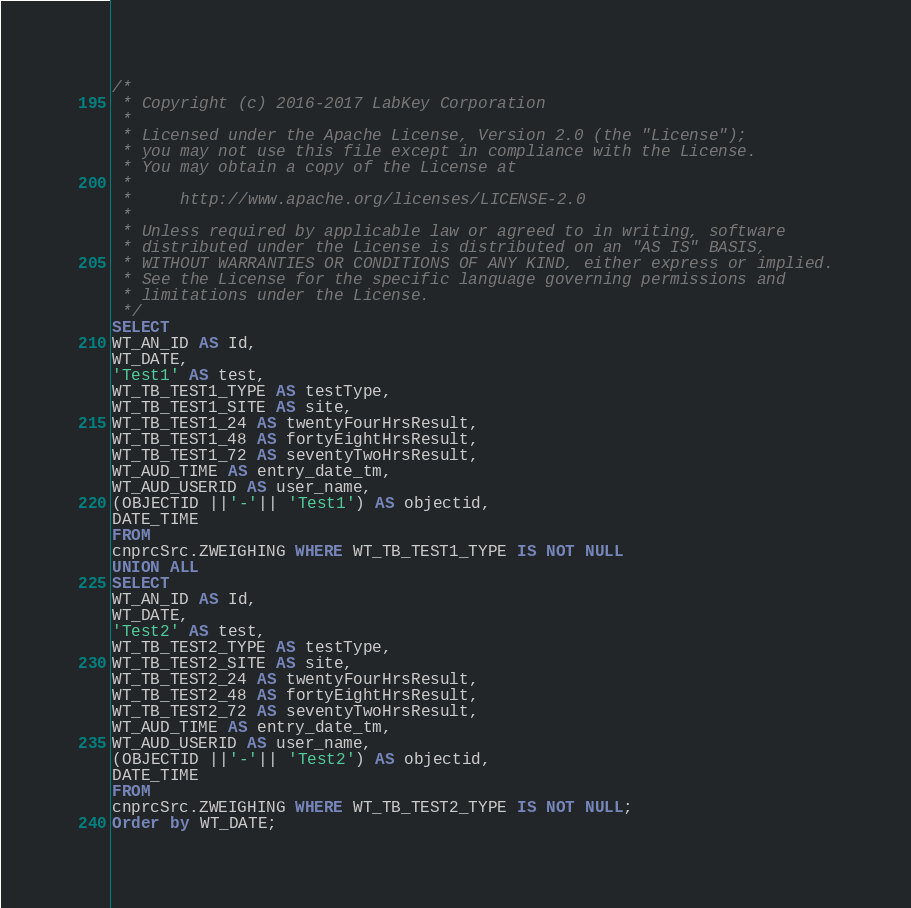<code> <loc_0><loc_0><loc_500><loc_500><_SQL_>/*
 * Copyright (c) 2016-2017 LabKey Corporation
 *
 * Licensed under the Apache License, Version 2.0 (the "License");
 * you may not use this file except in compliance with the License.
 * You may obtain a copy of the License at
 *
 *     http://www.apache.org/licenses/LICENSE-2.0
 *
 * Unless required by applicable law or agreed to in writing, software
 * distributed under the License is distributed on an "AS IS" BASIS,
 * WITHOUT WARRANTIES OR CONDITIONS OF ANY KIND, either express or implied.
 * See the License for the specific language governing permissions and
 * limitations under the License.
 */
SELECT 
WT_AN_ID AS Id,
WT_DATE,
'Test1' AS test,
WT_TB_TEST1_TYPE AS testType,
WT_TB_TEST1_SITE AS site,
WT_TB_TEST1_24 AS twentyFourHrsResult,
WT_TB_TEST1_48 AS fortyEightHrsResult,
WT_TB_TEST1_72 AS seventyTwoHrsResult,
WT_AUD_TIME AS entry_date_tm,
WT_AUD_USERID AS user_name,
(OBJECTID ||'-'|| 'Test1') AS objectid,
DATE_TIME
FROM
cnprcSrc.ZWEIGHING WHERE WT_TB_TEST1_TYPE IS NOT NULL
UNION ALL
SELECT
WT_AN_ID AS Id,
WT_DATE,
'Test2' AS test,
WT_TB_TEST2_TYPE AS testType,
WT_TB_TEST2_SITE AS site,
WT_TB_TEST2_24 AS twentyFourHrsResult,
WT_TB_TEST2_48 AS fortyEightHrsResult,
WT_TB_TEST2_72 AS seventyTwoHrsResult,
WT_AUD_TIME AS entry_date_tm,
WT_AUD_USERID AS user_name,
(OBJECTID ||'-'|| 'Test2') AS objectid,
DATE_TIME
FROM
cnprcSrc.ZWEIGHING WHERE WT_TB_TEST2_TYPE IS NOT NULL;
Order by WT_DATE;</code> 